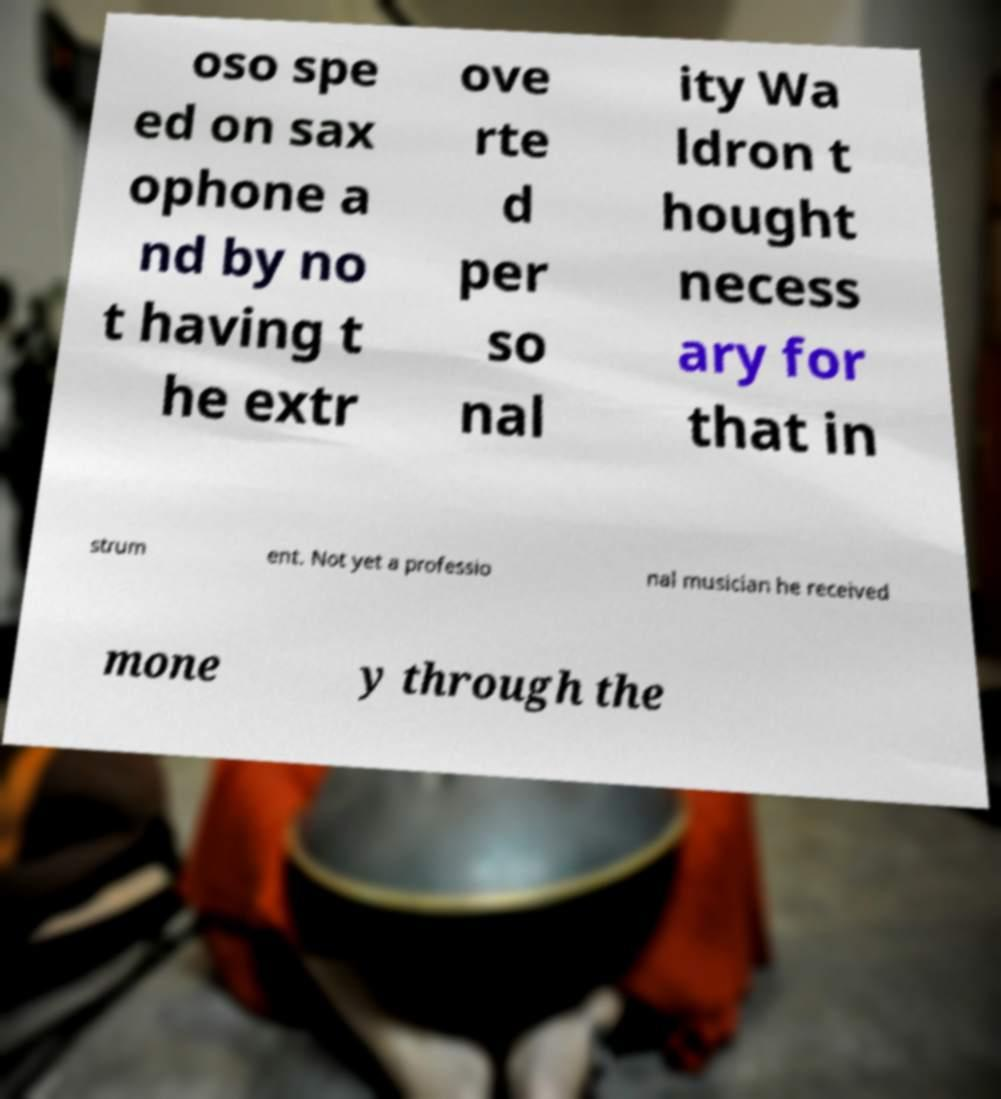What messages or text are displayed in this image? I need them in a readable, typed format. oso spe ed on sax ophone a nd by no t having t he extr ove rte d per so nal ity Wa ldron t hought necess ary for that in strum ent. Not yet a professio nal musician he received mone y through the 